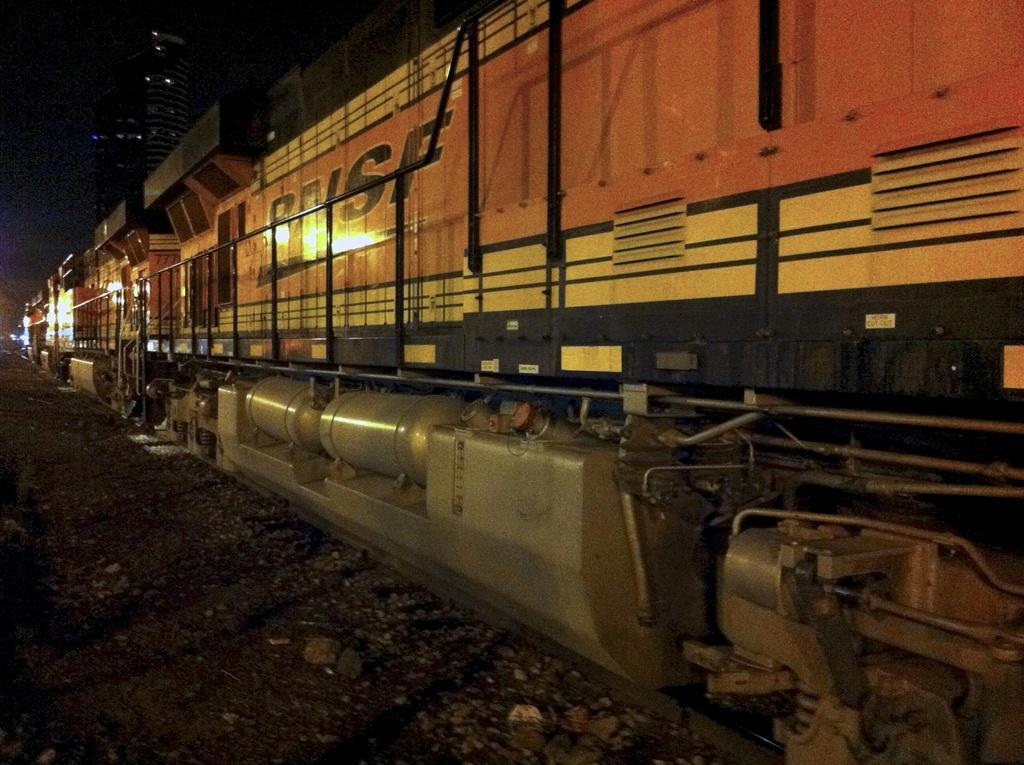How would you summarize this image in a sentence or two? In this image we can see a train on the railway track and a dark background. 